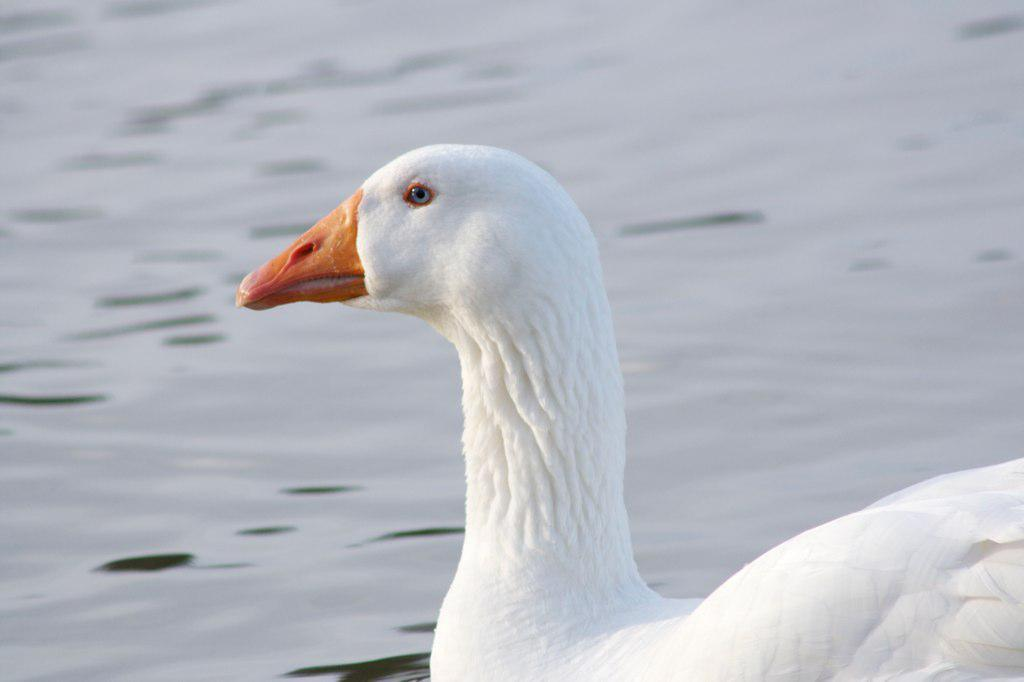What type of animal can be seen in the image? There is a bird in the image. Where is the bird located in the image? The bird is on the water. What is the bird's observation about the voyage in the image? There is no information about a voyage or the bird's observation in the image. 